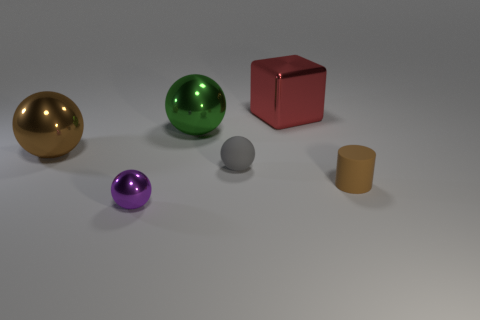There is a sphere behind the large shiny thing that is in front of the green sphere; how big is it?
Ensure brevity in your answer.  Large. What is the object that is on the right side of the metallic cube made of?
Ensure brevity in your answer.  Rubber. What is the size of the thing that is made of the same material as the tiny gray sphere?
Offer a very short reply. Small. How many small rubber things have the same shape as the large green thing?
Provide a short and direct response. 1. There is a brown shiny thing; does it have the same shape as the matte thing to the right of the large metal block?
Provide a succinct answer. No. There is a big object that is the same color as the small cylinder; what shape is it?
Your answer should be compact. Sphere. Is there a large red block that has the same material as the large brown object?
Offer a very short reply. Yes. Are there any other things that are made of the same material as the purple thing?
Provide a short and direct response. Yes. What is the small sphere that is on the left side of the shiny ball that is behind the big brown object made of?
Keep it short and to the point. Metal. There is a ball in front of the brown thing that is on the right side of the big metallic ball that is on the left side of the purple ball; what is its size?
Provide a short and direct response. Small. 